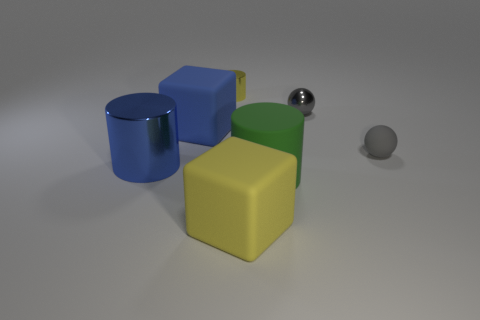There is a block that is left of the tiny object that is left of the gray metal object; what is it made of?
Your answer should be very brief. Rubber. What number of objects are left of the green rubber thing and in front of the big blue block?
Make the answer very short. 2. How many other objects are there of the same size as the green object?
Ensure brevity in your answer.  3. There is a large object that is in front of the green rubber cylinder; is its shape the same as the tiny gray thing that is behind the gray matte ball?
Keep it short and to the point. No. There is a gray rubber object; are there any tiny metallic objects to the right of it?
Ensure brevity in your answer.  No. There is another matte object that is the same shape as the blue rubber object; what is its color?
Make the answer very short. Yellow. Are there any other things that are the same shape as the large blue matte thing?
Your answer should be compact. Yes. What is the material of the small ball that is in front of the blue matte object?
Your answer should be compact. Rubber. What size is the other object that is the same shape as the tiny matte object?
Offer a terse response. Small. How many tiny gray balls have the same material as the big green object?
Make the answer very short. 1. 